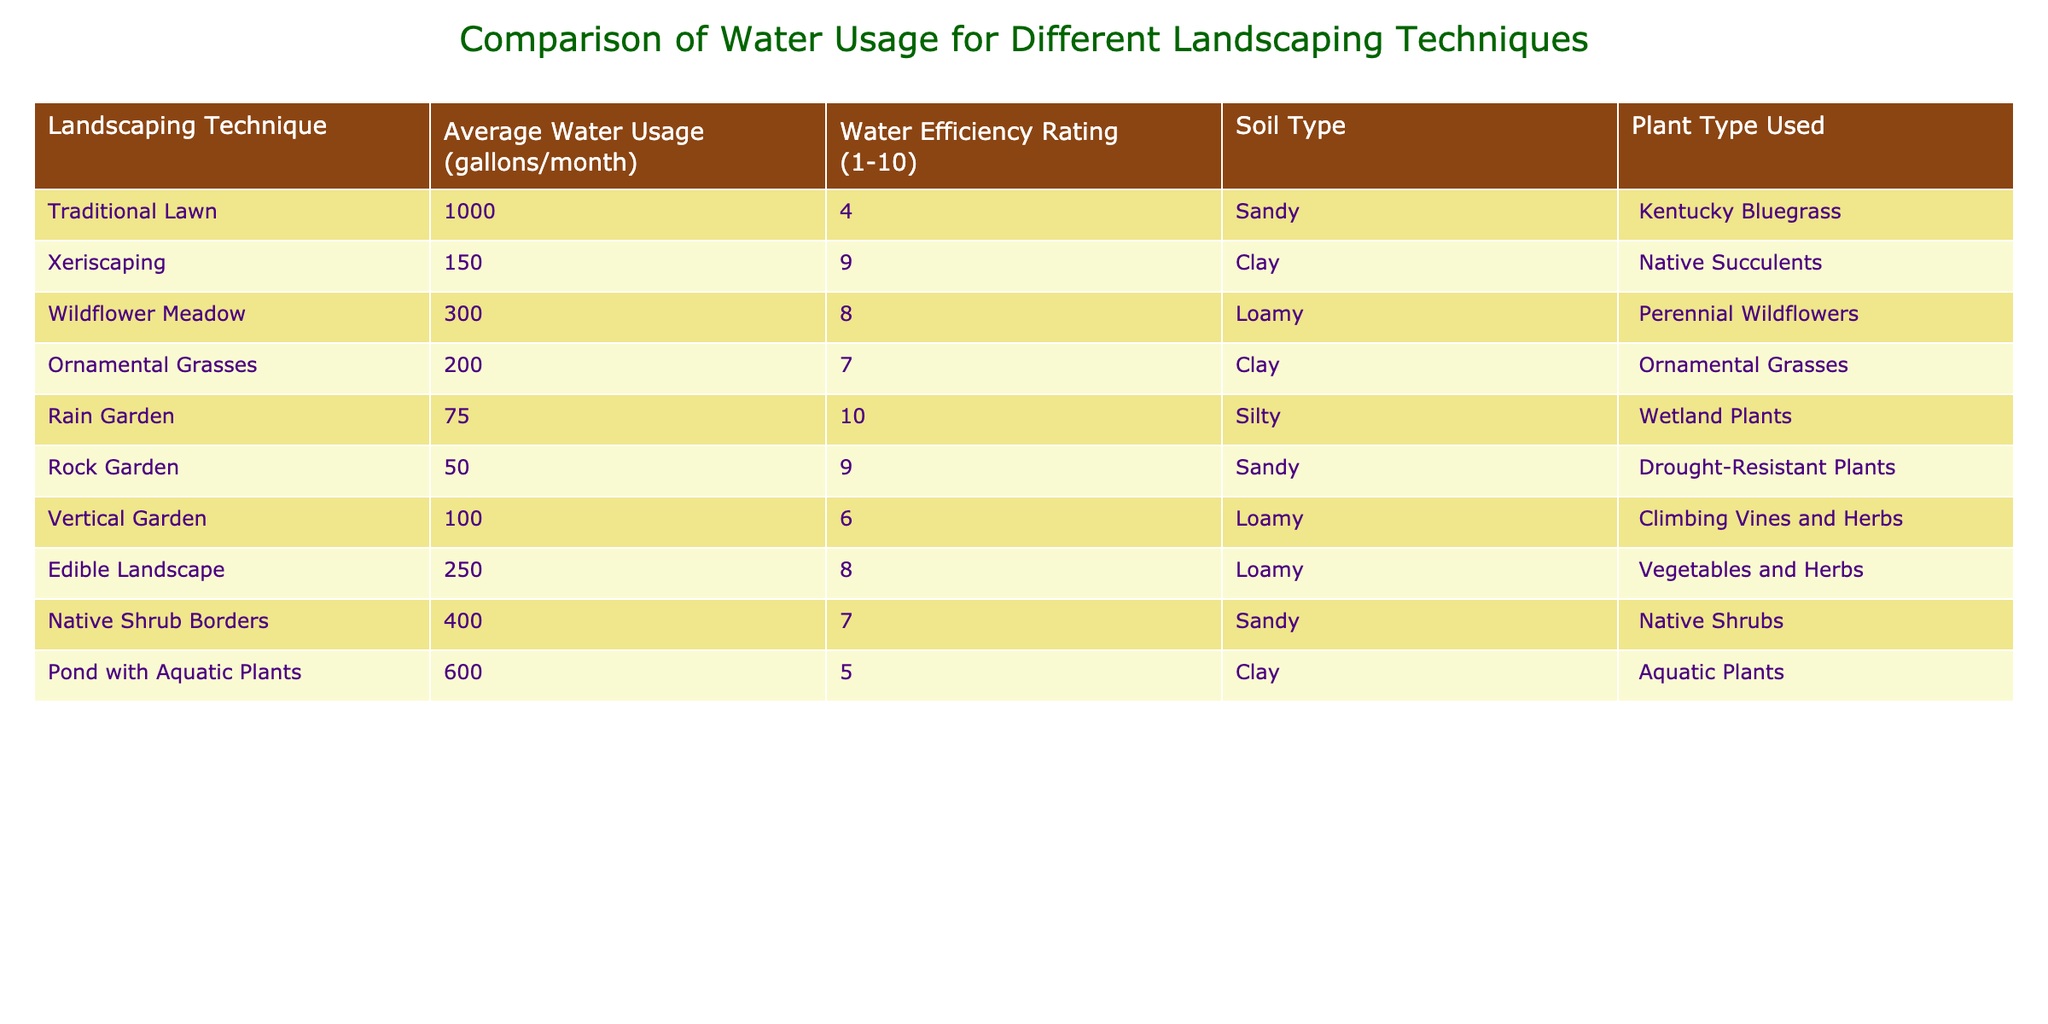What is the average water usage of Xeriscaping? The table shows that Xeriscaping has an average water usage of 150 gallons/month.
Answer: 150 Which landscaping technique has the highest water efficiency rating? In the table, Rain Garden and Xeriscaping both have a water efficiency rating of 10, which is the highest.
Answer: Rain Garden and Xeriscaping How much more water does Traditional Lawn use compared to Rock Garden? Traditional Lawn uses 1000 gallons/month and Rock Garden uses 50 gallons/month. Therefore, the difference in water usage is 1000 - 50 = 950 gallons/month.
Answer: 950 Is the water efficiency rating of Wildflower Meadow greater than that of Edible Landscape? Wildflower Meadow has a water efficiency rating of 8, while Edible Landscape has a rating of 8 as well. Therefore, the statement is false; they have the same rating.
Answer: No What is the total average water usage of Native Shrub Borders and Pond with Aquatic Plants? Native Shrub Borders uses 400 gallons/month and Pond with Aquatic Plants uses 600 gallons/month. Adding these values gives 400 + 600 = 1000 gallons/month for both.
Answer: 1000 Which soil type is used for the Xeriscaping technique? According to the table, the soil type for Xeriscaping is Clay.
Answer: Clay If a garden were to use only the water-efficient techniques (Rain Garden, Xeriscaping, Rock Garden), what would be the total average water usage? The average water usage for each of these techniques is: Rain Garden 75 gallons/month, Xeriscaping 150 gallons/month, and Rock Garden 50 gallons/month. Therefore, the total is 75 + 150 + 50 = 275 gallons/month.
Answer: 275 Are Ornamental Grasses and Native Shrub Borders both rated 7 for water efficiency? Ornamental Grasses have a water efficiency rating of 7, while Native Shrub Borders also have a rating of 7. Thus, the statement is true.
Answer: Yes What is the average water usage of the landscaping techniques that use Loamy soil? The landscaping techniques using Loamy soil are Wildflower Meadow, Vertical Garden, and Edible Landscape, with an average water usage of 300, 100, and 250 gallons/month respectively. The total is 300 + 100 + 250 = 650 gallons/month, and dividing by 3 gives an average of 650 / 3 ≈ 216.67 gallons/month.
Answer: Approximately 216.67 